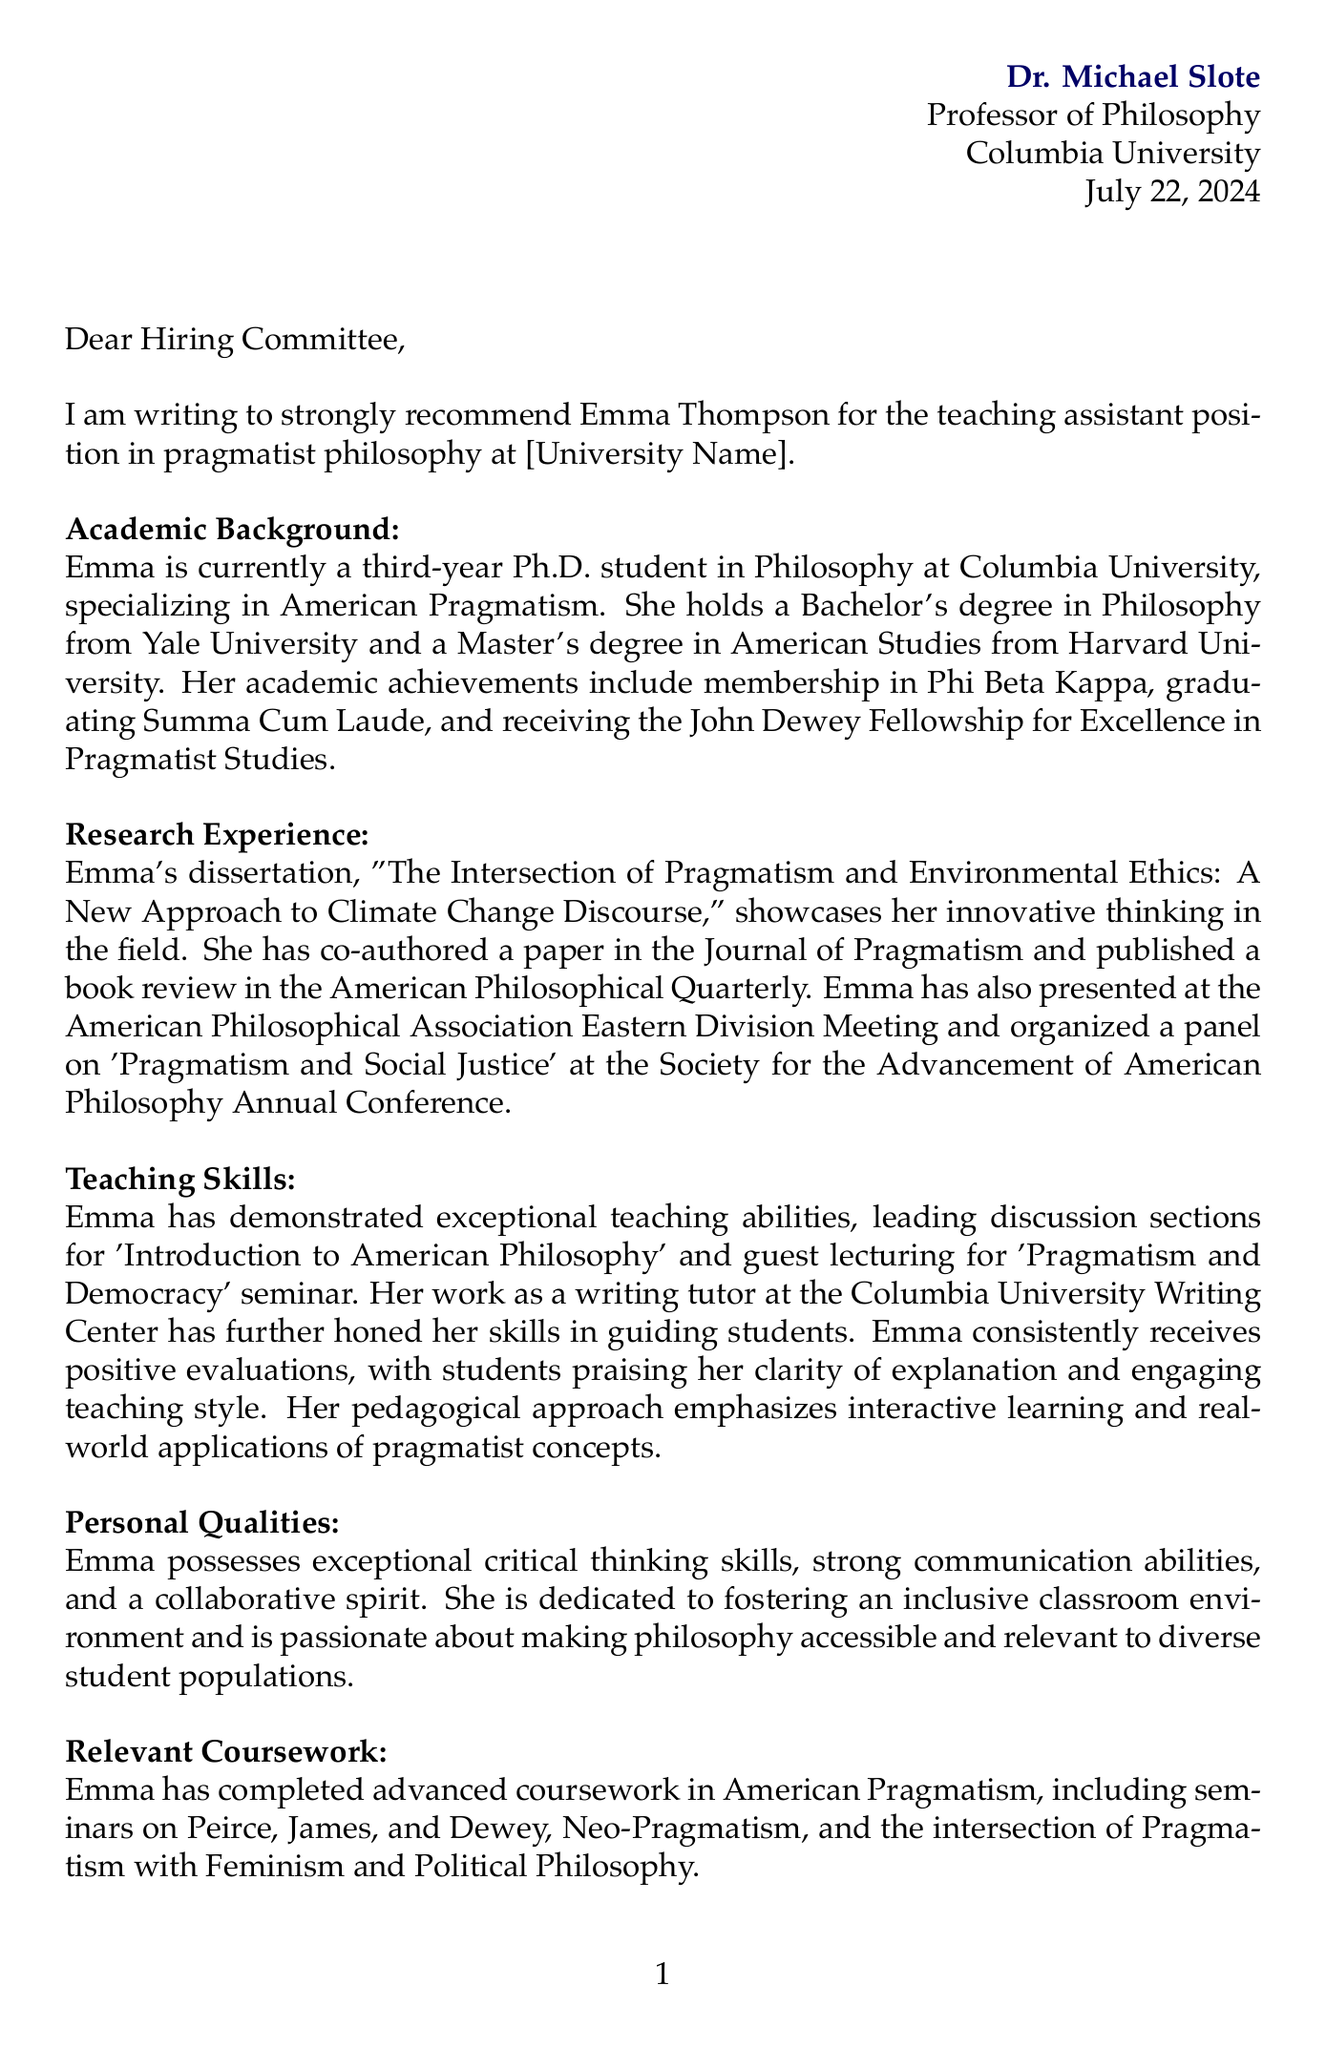What is the name of the student being recommended? The name of the student is explicitly stated in the opening lines of the document.
Answer: Emma Thompson What position is Emma Thompson applying for? The specific position is mentioned in the opening statement of the letter.
Answer: Teaching assistant position in pragmatist philosophy Which university is Dr. Michael Slote affiliated with? The document clearly states the professor's university affiliation at the beginning.
Answer: Columbia University What is the title of Emma's dissertation? The title of the dissertation is mentioned in the research experience section of the letter.
Answer: The Intersection of Pragmatism and Environmental Ethics: A New Approach to Climate Change Discourse What is one of Emma's academic achievements? Several achievements are highlighted, one of which is described in the academic background section.
Answer: Recipient of the John Dewey Fellowship for Excellence in Pragmatist Studies What teaching skill is emphasized in Emma's evaluations? The document includes student feedback regarding Emma's teaching abilities in the teaching skills section.
Answer: Clarity of explanation How does Emma approach her teaching? The letter explicitly describes her pedagogical approach, which is a key point in the teaching skills section.
Answer: Emphasizes interactive learning What is the main subject of the coursework Emma has completed? The relevant coursework section summarizes the focus of Emma's studies.
Answer: American Pragmatism What personal quality is highlighted regarding Emma's collaboration? The document lists personal qualities in the paragraph about Emma’s personal characteristics.
Answer: Collaborative spirit 